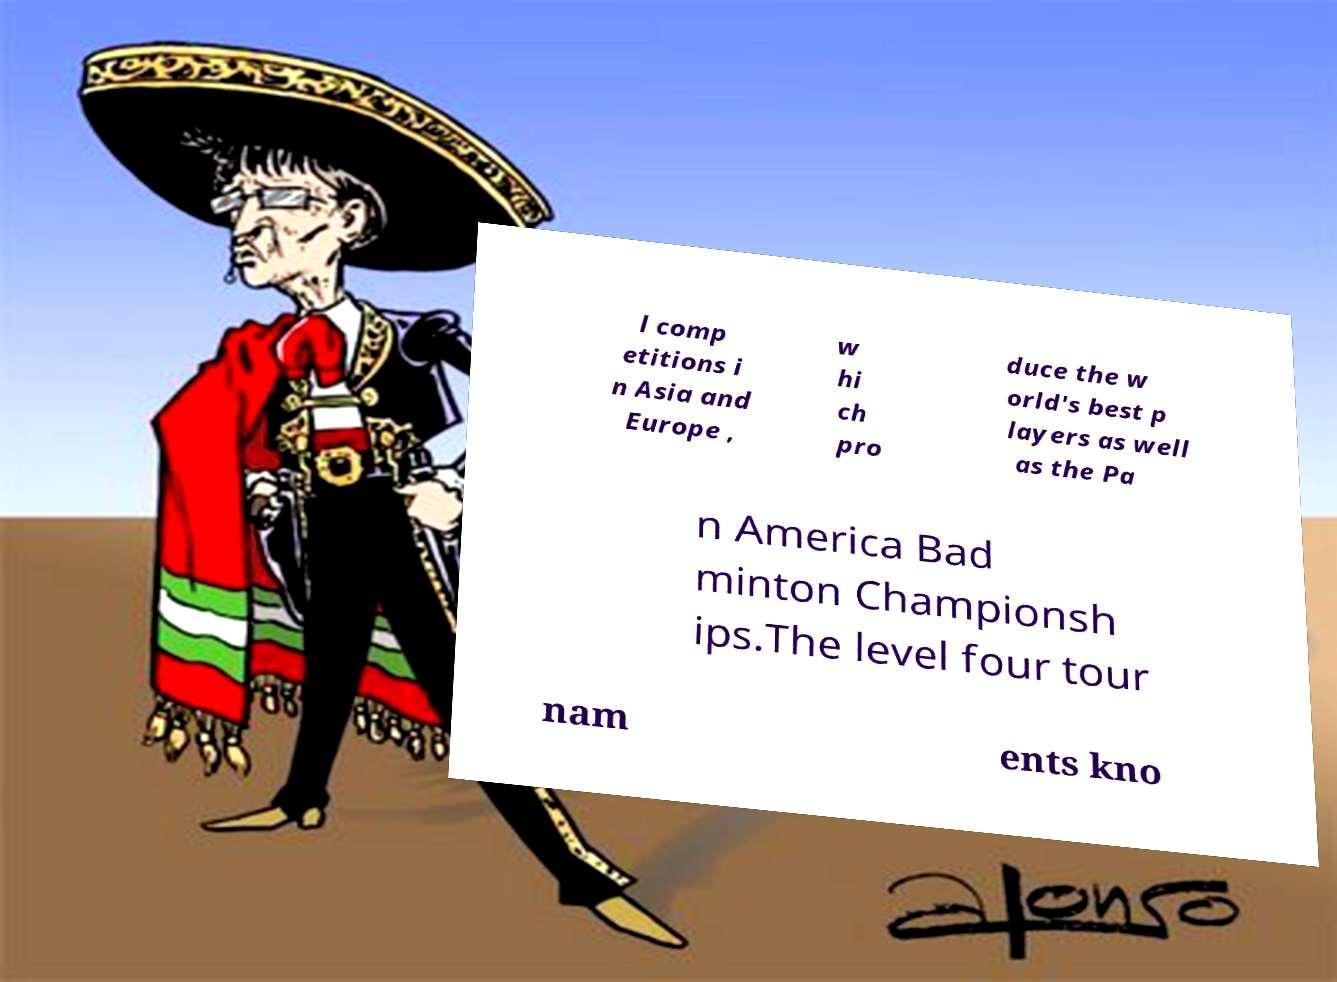Can you accurately transcribe the text from the provided image for me? l comp etitions i n Asia and Europe , w hi ch pro duce the w orld's best p layers as well as the Pa n America Bad minton Championsh ips.The level four tour nam ents kno 